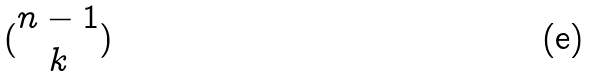Convert formula to latex. <formula><loc_0><loc_0><loc_500><loc_500>( \begin{matrix} n - 1 \\ k \end{matrix} )</formula> 